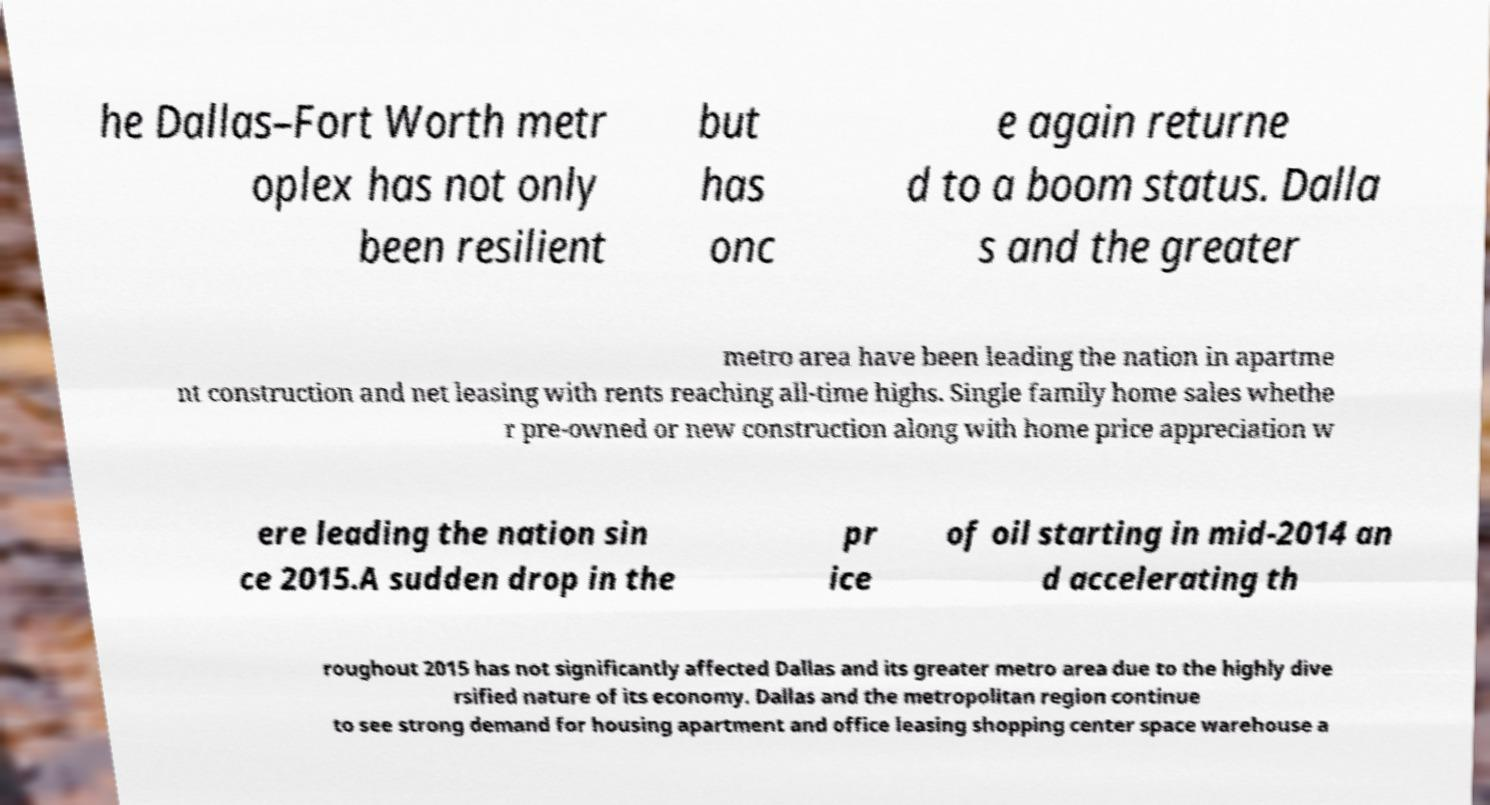Can you accurately transcribe the text from the provided image for me? he Dallas–Fort Worth metr oplex has not only been resilient but has onc e again returne d to a boom status. Dalla s and the greater metro area have been leading the nation in apartme nt construction and net leasing with rents reaching all-time highs. Single family home sales whethe r pre-owned or new construction along with home price appreciation w ere leading the nation sin ce 2015.A sudden drop in the pr ice of oil starting in mid-2014 an d accelerating th roughout 2015 has not significantly affected Dallas and its greater metro area due to the highly dive rsified nature of its economy. Dallas and the metropolitan region continue to see strong demand for housing apartment and office leasing shopping center space warehouse a 